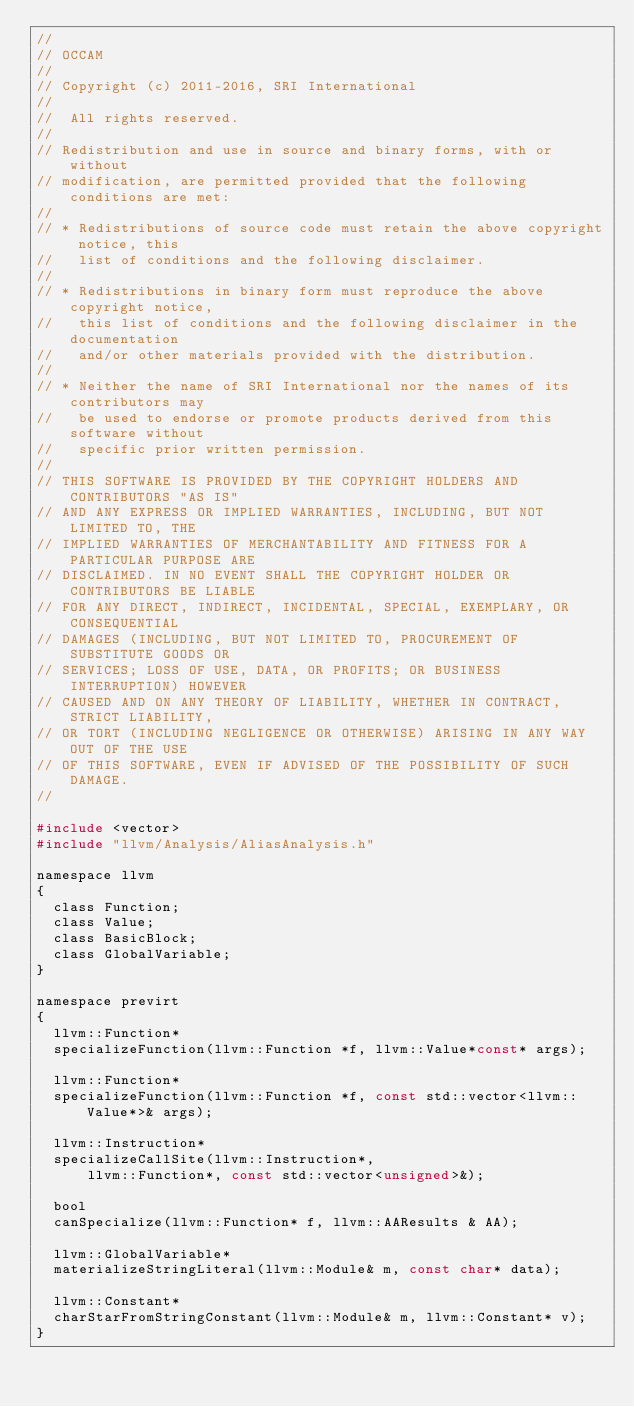<code> <loc_0><loc_0><loc_500><loc_500><_C_>//
// OCCAM
//
// Copyright (c) 2011-2016, SRI International
//
//  All rights reserved.
//
// Redistribution and use in source and binary forms, with or without
// modification, are permitted provided that the following conditions are met:
//
// * Redistributions of source code must retain the above copyright notice, this
//   list of conditions and the following disclaimer.
//
// * Redistributions in binary form must reproduce the above copyright notice,
//   this list of conditions and the following disclaimer in the documentation
//   and/or other materials provided with the distribution.
//
// * Neither the name of SRI International nor the names of its contributors may
//   be used to endorse or promote products derived from this software without
//   specific prior written permission.
//
// THIS SOFTWARE IS PROVIDED BY THE COPYRIGHT HOLDERS AND CONTRIBUTORS "AS IS"
// AND ANY EXPRESS OR IMPLIED WARRANTIES, INCLUDING, BUT NOT LIMITED TO, THE
// IMPLIED WARRANTIES OF MERCHANTABILITY AND FITNESS FOR A PARTICULAR PURPOSE ARE
// DISCLAIMED. IN NO EVENT SHALL THE COPYRIGHT HOLDER OR CONTRIBUTORS BE LIABLE
// FOR ANY DIRECT, INDIRECT, INCIDENTAL, SPECIAL, EXEMPLARY, OR CONSEQUENTIAL
// DAMAGES (INCLUDING, BUT NOT LIMITED TO, PROCUREMENT OF SUBSTITUTE GOODS OR
// SERVICES; LOSS OF USE, DATA, OR PROFITS; OR BUSINESS INTERRUPTION) HOWEVER
// CAUSED AND ON ANY THEORY OF LIABILITY, WHETHER IN CONTRACT, STRICT LIABILITY,
// OR TORT (INCLUDING NEGLIGENCE OR OTHERWISE) ARISING IN ANY WAY OUT OF THE USE
// OF THIS SOFTWARE, EVEN IF ADVISED OF THE POSSIBILITY OF SUCH DAMAGE.
//

#include <vector>
#include "llvm/Analysis/AliasAnalysis.h"

namespace llvm
{
  class Function;
  class Value;
  class BasicBlock;
  class GlobalVariable;
}

namespace previrt
{
  llvm::Function*
  specializeFunction(llvm::Function *f, llvm::Value*const* args);

  llvm::Function*
  specializeFunction(llvm::Function *f, const std::vector<llvm::Value*>& args);

  llvm::Instruction*
  specializeCallSite(llvm::Instruction*,
      llvm::Function*, const std::vector<unsigned>&);

  bool
  canSpecialize(llvm::Function* f, llvm::AAResults & AA);

  llvm::GlobalVariable*
  materializeStringLiteral(llvm::Module& m, const char* data);

  llvm::Constant*
  charStarFromStringConstant(llvm::Module& m, llvm::Constant* v);
}
</code> 